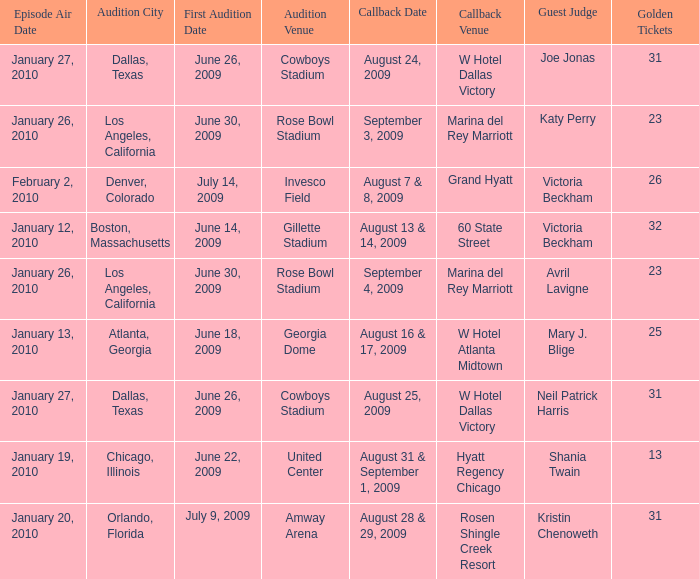Name the audition city for hyatt regency chicago Chicago, Illinois. 